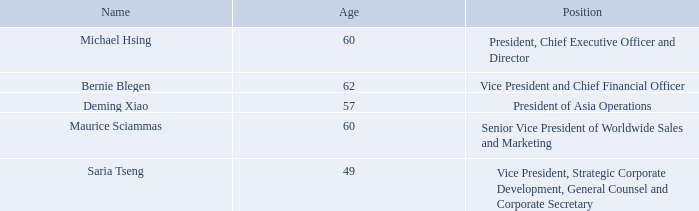Information About Executive Officers
Information regarding our executive officers as of February 28, 2020 is as follows:
Michael Hsing has served on our Board of Directors and has served as our President and Chief Executive Officer since founding MPS in August 1997. Prior to founding MPS, Mr. Hsing was a Senior Silicon Technology Developer at several analog IC companies, where he developed and patented key technologies, which set new standards in the power electronics industry. Mr. Hsing is an inventor on numerous patents related to the process development of bipolar mixed-signal semiconductor manufacturing. Mr. Hsing holds a B.S.E.E. from the University of Florida.
Bernie Blegen has served as our Chief Financial Officer since July 2016 and is responsible for finance, accounting, tax, treasury and investor relations. From August 2011 to June 2016, Mr. Blegen served as our Corporate Controller. Prior to joining MPS, Mr. Blegen held a number of executive finance and accounting positions for other publicly traded technology companies, including Xilinx, Inc. and Credence Systems. Mr. Blegen holds a B.A. from the University of California, Santa Barbara.
Deming Xiao has served as our President of Asia Operations since January 2008. Since joining us in May 2001, Mr. Xiao has held several executive positions, including Foundry Manager and Senior Vice President of Operations. Before joining MPS, from June 2000 to May 2001, Mr. Xiao was Engineering Account Manager at Chartered Semiconductor Manufacturing, Inc. Prior to that, Mr. Xiao spent six years as the Manager of Process Integration Engineering at Fairchild Imaging Sensors. Mr. Xiao holds a B.S. in Semiconductor Physics from Sichuan University, Chengdu, China and an M.S.E.E. from Wayne State University.
Maurice Sciammas has served as our Senior Vice President of Worldwide Sales and Marketing since 2007. Mr. Sciammas joined MPS in July 1999 and served as Vice President of Products and Vice President of Sales (excluding greater China) until he was appointed to his current position. Before joining MPS, he was Director of IC Products at Supertex from 1990 to 1999. He has also held positions at Micrel, Inc. He holds a B.S.E.E. degree from San Jose State University.
Saria Tseng has served as our Vice President, General Counsel and Corporate Secretary since 2004 and additionally as our Vice President, Strategic Corporate Development since 2009. Ms. Tseng joined the Company from MaXXan Systems, Inc., where she was Vice President and General Counsel from 2001 to 2004. Previously, Ms. Tseng was an attorney at Gray Cary Ware & Freidenrich, LLP and Jones, Day, Reavis & Pogue. Ms. Tseng is a member of the state bar in both California and New York and is a member of the bar association of the Republic of China (Taiwan). Ms. Tseng currently serves on the Board of Directors of Super Micro Computer, Inc., a global leader in high performance server technology. Ms. Tseng holds Masters of Law degrees from the University of California at Berkeley and the Chinese Culture University in Taipei.
What is Michael Hsing's position in MPS? President and chief executive officer. Where did Mr Xiao work just before joining MPS? Chartered semiconductor manufacturing, inc. Which universities did Mr Hsing and Mr Blegen graduate from respectively? University of florida, university of california, santa barbara. What is the average age of the Executive Officers?  (60+62+57+60+49)/5
Answer: 57.6. For how many years has Mr Sciammas served as the company's Senior Vice President of Worldwide Sales and Marketing? 2020-2007
Answer: 13. What is the collective number of years that Mr Xiao and Mr Sciammas have been working for at MPS? 2020-2001 + 2020-1999
Answer: 40. 